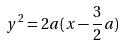<formula> <loc_0><loc_0><loc_500><loc_500>y ^ { 2 } = 2 a ( x - \frac { 3 } { 2 } a )</formula> 